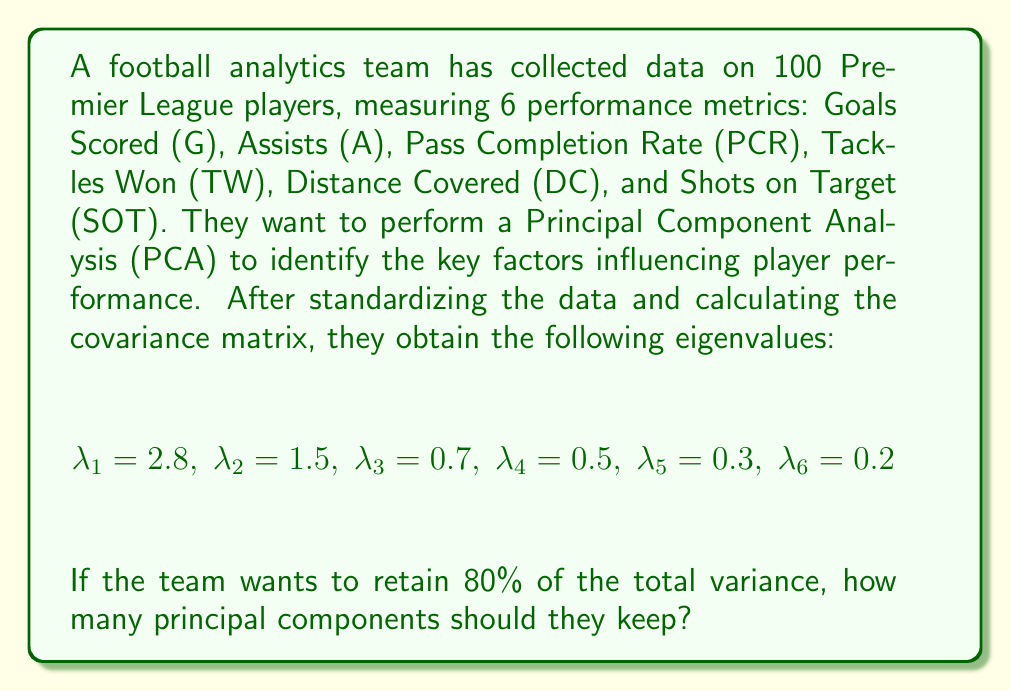Give your solution to this math problem. To solve this problem, we need to follow these steps:

1) First, calculate the total variance:
   $$\text{Total Variance} = \sum_{i=1}^6 \lambda_i = 2.8 + 1.5 + 0.7 + 0.5 + 0.3 + 0.2 = 6$$

2) Calculate the proportion of variance explained by each component:
   $$\text{Proportion}_i = \frac{\lambda_i}{\text{Total Variance}}$$

   For the first component: $\frac{2.8}{6} = 0.4667$ or 46.67%
   For the second component: $\frac{1.5}{6} = 0.2500$ or 25.00%
   For the third component: $\frac{0.7}{6} = 0.1167$ or 11.67%
   For the fourth component: $\frac{0.5}{6} = 0.0833$ or 8.33%
   For the fifth component: $\frac{0.3}{6} = 0.0500$ or 5.00%
   For the sixth component: $\frac{0.2}{6} = 0.0333$ or 3.33%

3) Calculate the cumulative proportion of variance:
   First component: 46.67%
   First two components: 46.67% + 25.00% = 71.67%
   First three components: 71.67% + 11.67% = 83.34%

4) We need to retain at least 80% of the total variance. The first two components explain 71.67% of the variance, which is not enough. However, the first three components explain 83.34% of the variance, which exceeds the 80% threshold.

Therefore, the team should keep 3 principal components to retain at least 80% of the total variance.
Answer: 3 principal components 